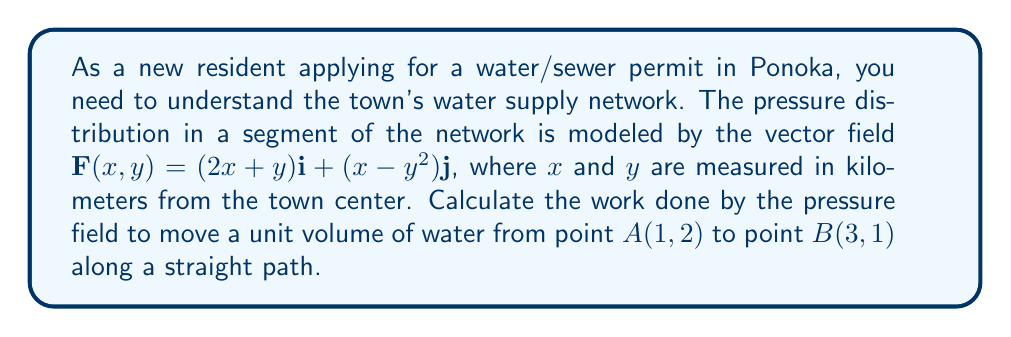Can you answer this question? To solve this problem, we'll follow these steps:

1) The work done by a vector field $\mathbf{F}$ along a path $C$ from point $A$ to point $B$ is given by the line integral:

   $$W = \int_C \mathbf{F} \cdot d\mathbf{r}$$

2) For a straight path, we can parameterize the path using:
   
   $$\mathbf{r}(t) = (1-t)\mathbf{A} + t\mathbf{B}, \quad 0 \leq t \leq 1$$

   where $\mathbf{A} = (1,2)$ and $\mathbf{B} = (3,1)$

3) Substituting:

   $$\mathbf{r}(t) = (1-t)(1,2) + t(3,1) = (1+2t, 2-t)$$

4) The differential $d\mathbf{r}$ is:

   $$d\mathbf{r} = (2dt, -dt)$$

5) Now, we need to evaluate $\mathbf{F}$ along the path:

   $$\mathbf{F}(\mathbf{r}(t)) = (2(1+2t)+(2-t))\mathbf{i} + ((1+2t)-(2-t)^2)\mathbf{j}$$
   $$= (4+3t)\mathbf{i} + (1+2t-(4-4t+t^2))\mathbf{j}$$
   $$= (4+3t)\mathbf{i} + (-3+6t-t^2)\mathbf{j}$$

6) The dot product $\mathbf{F} \cdot d\mathbf{r}$ is:

   $$\mathbf{F} \cdot d\mathbf{r} = (4+3t)(2dt) + (-3+6t-t^2)(-dt)$$
   $$= (8+6t)dt + (3-6t+t^2)dt$$
   $$= (11-t+t^2)dt$$

7) Now we integrate from $t=0$ to $t=1$:

   $$W = \int_0^1 (11-t+t^2)dt = [11t - \frac{t^2}{2} + \frac{t^3}{3}]_0^1$$
   $$= (11 - \frac{1}{2} + \frac{1}{3}) - (0 - 0 + 0) = \frac{65}{6}$$

Therefore, the work done is $\frac{65}{6}$ (in appropriate units of pressure * volume).
Answer: $\frac{65}{6}$ 